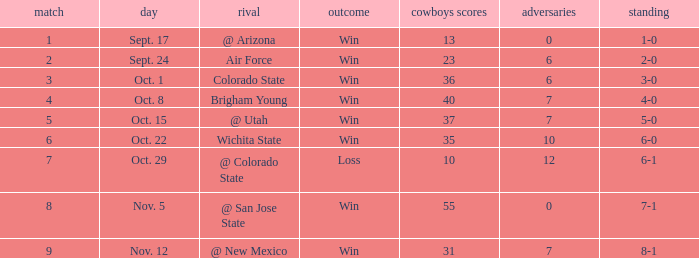Could you help me parse every detail presented in this table? {'header': ['match', 'day', 'rival', 'outcome', 'cowboys scores', 'adversaries', 'standing'], 'rows': [['1', 'Sept. 17', '@ Arizona', 'Win', '13', '0', '1-0'], ['2', 'Sept. 24', 'Air Force', 'Win', '23', '6', '2-0'], ['3', 'Oct. 1', 'Colorado State', 'Win', '36', '6', '3-0'], ['4', 'Oct. 8', 'Brigham Young', 'Win', '40', '7', '4-0'], ['5', 'Oct. 15', '@ Utah', 'Win', '37', '7', '5-0'], ['6', 'Oct. 22', 'Wichita State', 'Win', '35', '10', '6-0'], ['7', 'Oct. 29', '@ Colorado State', 'Loss', '10', '12', '6-1'], ['8', 'Nov. 5', '@ San Jose State', 'Win', '55', '0', '7-1'], ['9', 'Nov. 12', '@ New Mexico', 'Win', '31', '7', '8-1']]} What was the Cowboys' record for Nov. 5, 1966? 7-1. 